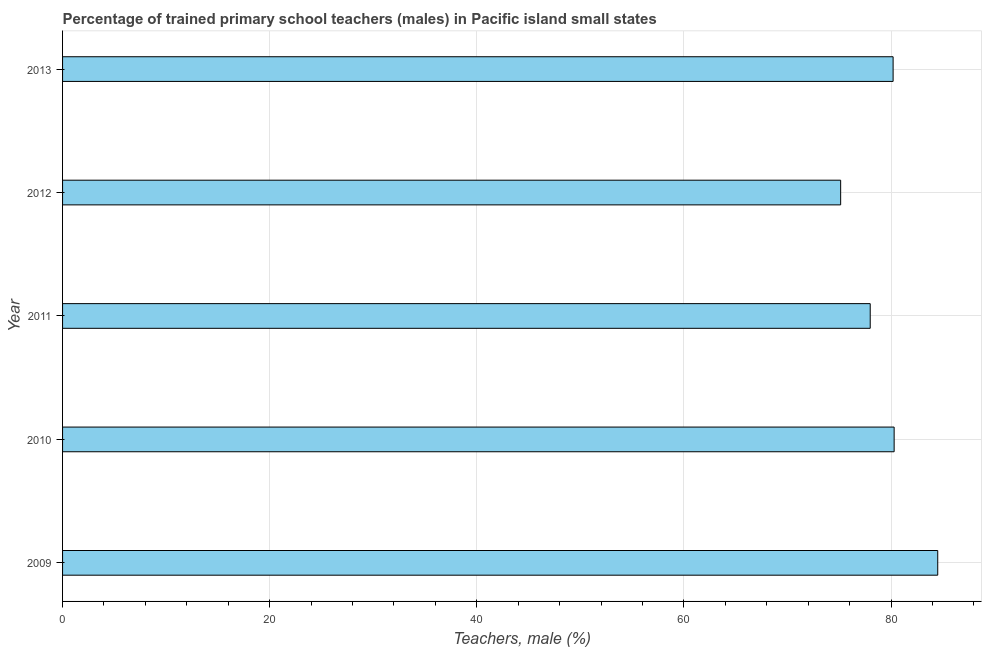Does the graph contain any zero values?
Make the answer very short. No. Does the graph contain grids?
Make the answer very short. Yes. What is the title of the graph?
Provide a short and direct response. Percentage of trained primary school teachers (males) in Pacific island small states. What is the label or title of the X-axis?
Your answer should be compact. Teachers, male (%). What is the label or title of the Y-axis?
Your answer should be very brief. Year. What is the percentage of trained male teachers in 2009?
Ensure brevity in your answer.  84.51. Across all years, what is the maximum percentage of trained male teachers?
Offer a very short reply. 84.51. Across all years, what is the minimum percentage of trained male teachers?
Your response must be concise. 75.14. In which year was the percentage of trained male teachers maximum?
Ensure brevity in your answer.  2009. In which year was the percentage of trained male teachers minimum?
Provide a succinct answer. 2012. What is the sum of the percentage of trained male teachers?
Offer a very short reply. 398.15. What is the difference between the percentage of trained male teachers in 2010 and 2012?
Your answer should be very brief. 5.17. What is the average percentage of trained male teachers per year?
Your answer should be compact. 79.63. What is the median percentage of trained male teachers?
Your response must be concise. 80.2. In how many years, is the percentage of trained male teachers greater than 52 %?
Your response must be concise. 5. Do a majority of the years between 2010 and 2013 (inclusive) have percentage of trained male teachers greater than 16 %?
Ensure brevity in your answer.  Yes. What is the ratio of the percentage of trained male teachers in 2010 to that in 2012?
Your response must be concise. 1.07. Is the difference between the percentage of trained male teachers in 2011 and 2012 greater than the difference between any two years?
Your response must be concise. No. What is the difference between the highest and the second highest percentage of trained male teachers?
Keep it short and to the point. 4.21. What is the difference between the highest and the lowest percentage of trained male teachers?
Your response must be concise. 9.37. How many bars are there?
Make the answer very short. 5. Are all the bars in the graph horizontal?
Your answer should be compact. Yes. What is the Teachers, male (%) of 2009?
Your answer should be compact. 84.51. What is the Teachers, male (%) of 2010?
Keep it short and to the point. 80.3. What is the Teachers, male (%) of 2011?
Offer a terse response. 77.99. What is the Teachers, male (%) in 2012?
Ensure brevity in your answer.  75.14. What is the Teachers, male (%) of 2013?
Provide a succinct answer. 80.2. What is the difference between the Teachers, male (%) in 2009 and 2010?
Provide a succinct answer. 4.21. What is the difference between the Teachers, male (%) in 2009 and 2011?
Provide a succinct answer. 6.52. What is the difference between the Teachers, male (%) in 2009 and 2012?
Give a very brief answer. 9.37. What is the difference between the Teachers, male (%) in 2009 and 2013?
Provide a short and direct response. 4.31. What is the difference between the Teachers, male (%) in 2010 and 2011?
Your response must be concise. 2.31. What is the difference between the Teachers, male (%) in 2010 and 2012?
Make the answer very short. 5.17. What is the difference between the Teachers, male (%) in 2010 and 2013?
Make the answer very short. 0.1. What is the difference between the Teachers, male (%) in 2011 and 2012?
Provide a succinct answer. 2.86. What is the difference between the Teachers, male (%) in 2011 and 2013?
Your answer should be very brief. -2.21. What is the difference between the Teachers, male (%) in 2012 and 2013?
Offer a very short reply. -5.07. What is the ratio of the Teachers, male (%) in 2009 to that in 2010?
Keep it short and to the point. 1.05. What is the ratio of the Teachers, male (%) in 2009 to that in 2011?
Give a very brief answer. 1.08. What is the ratio of the Teachers, male (%) in 2009 to that in 2012?
Give a very brief answer. 1.12. What is the ratio of the Teachers, male (%) in 2009 to that in 2013?
Keep it short and to the point. 1.05. What is the ratio of the Teachers, male (%) in 2010 to that in 2011?
Give a very brief answer. 1.03. What is the ratio of the Teachers, male (%) in 2010 to that in 2012?
Ensure brevity in your answer.  1.07. What is the ratio of the Teachers, male (%) in 2011 to that in 2012?
Your response must be concise. 1.04. What is the ratio of the Teachers, male (%) in 2011 to that in 2013?
Provide a short and direct response. 0.97. What is the ratio of the Teachers, male (%) in 2012 to that in 2013?
Give a very brief answer. 0.94. 